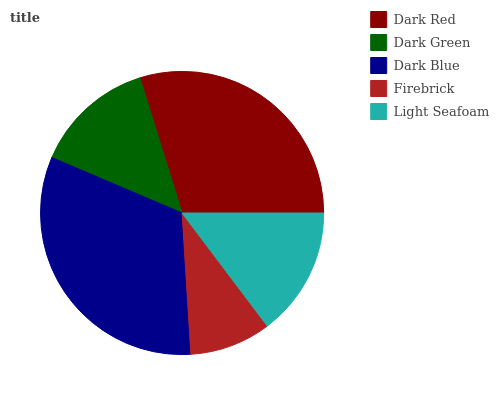Is Firebrick the minimum?
Answer yes or no. Yes. Is Dark Blue the maximum?
Answer yes or no. Yes. Is Dark Green the minimum?
Answer yes or no. No. Is Dark Green the maximum?
Answer yes or no. No. Is Dark Red greater than Dark Green?
Answer yes or no. Yes. Is Dark Green less than Dark Red?
Answer yes or no. Yes. Is Dark Green greater than Dark Red?
Answer yes or no. No. Is Dark Red less than Dark Green?
Answer yes or no. No. Is Light Seafoam the high median?
Answer yes or no. Yes. Is Light Seafoam the low median?
Answer yes or no. Yes. Is Dark Red the high median?
Answer yes or no. No. Is Dark Red the low median?
Answer yes or no. No. 